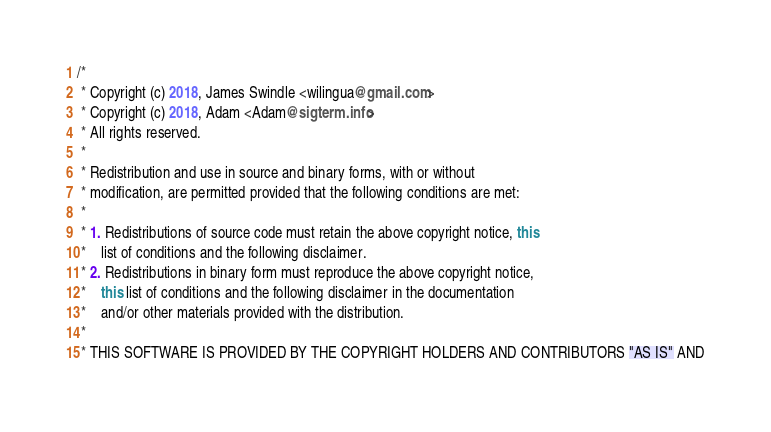Convert code to text. <code><loc_0><loc_0><loc_500><loc_500><_Java_>/*
 * Copyright (c) 2018, James Swindle <wilingua@gmail.com>
 * Copyright (c) 2018, Adam <Adam@sigterm.info>
 * All rights reserved.
 *
 * Redistribution and use in source and binary forms, with or without
 * modification, are permitted provided that the following conditions are met:
 *
 * 1. Redistributions of source code must retain the above copyright notice, this
 *    list of conditions and the following disclaimer.
 * 2. Redistributions in binary form must reproduce the above copyright notice,
 *    this list of conditions and the following disclaimer in the documentation
 *    and/or other materials provided with the distribution.
 *
 * THIS SOFTWARE IS PROVIDED BY THE COPYRIGHT HOLDERS AND CONTRIBUTORS "AS IS" AND</code> 